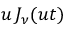<formula> <loc_0><loc_0><loc_500><loc_500>u \, J _ { \nu } ( u t )</formula> 